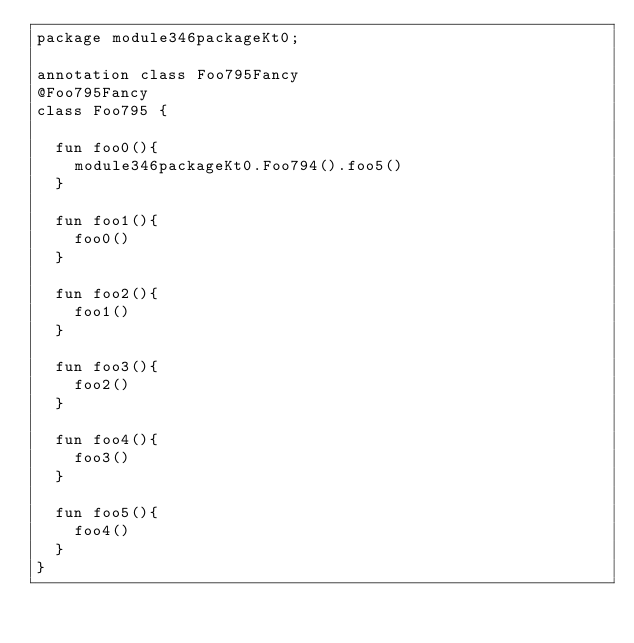Convert code to text. <code><loc_0><loc_0><loc_500><loc_500><_Kotlin_>package module346packageKt0;

annotation class Foo795Fancy
@Foo795Fancy
class Foo795 {

  fun foo0(){
    module346packageKt0.Foo794().foo5()
  }

  fun foo1(){
    foo0()
  }

  fun foo2(){
    foo1()
  }

  fun foo3(){
    foo2()
  }

  fun foo4(){
    foo3()
  }

  fun foo5(){
    foo4()
  }
}</code> 